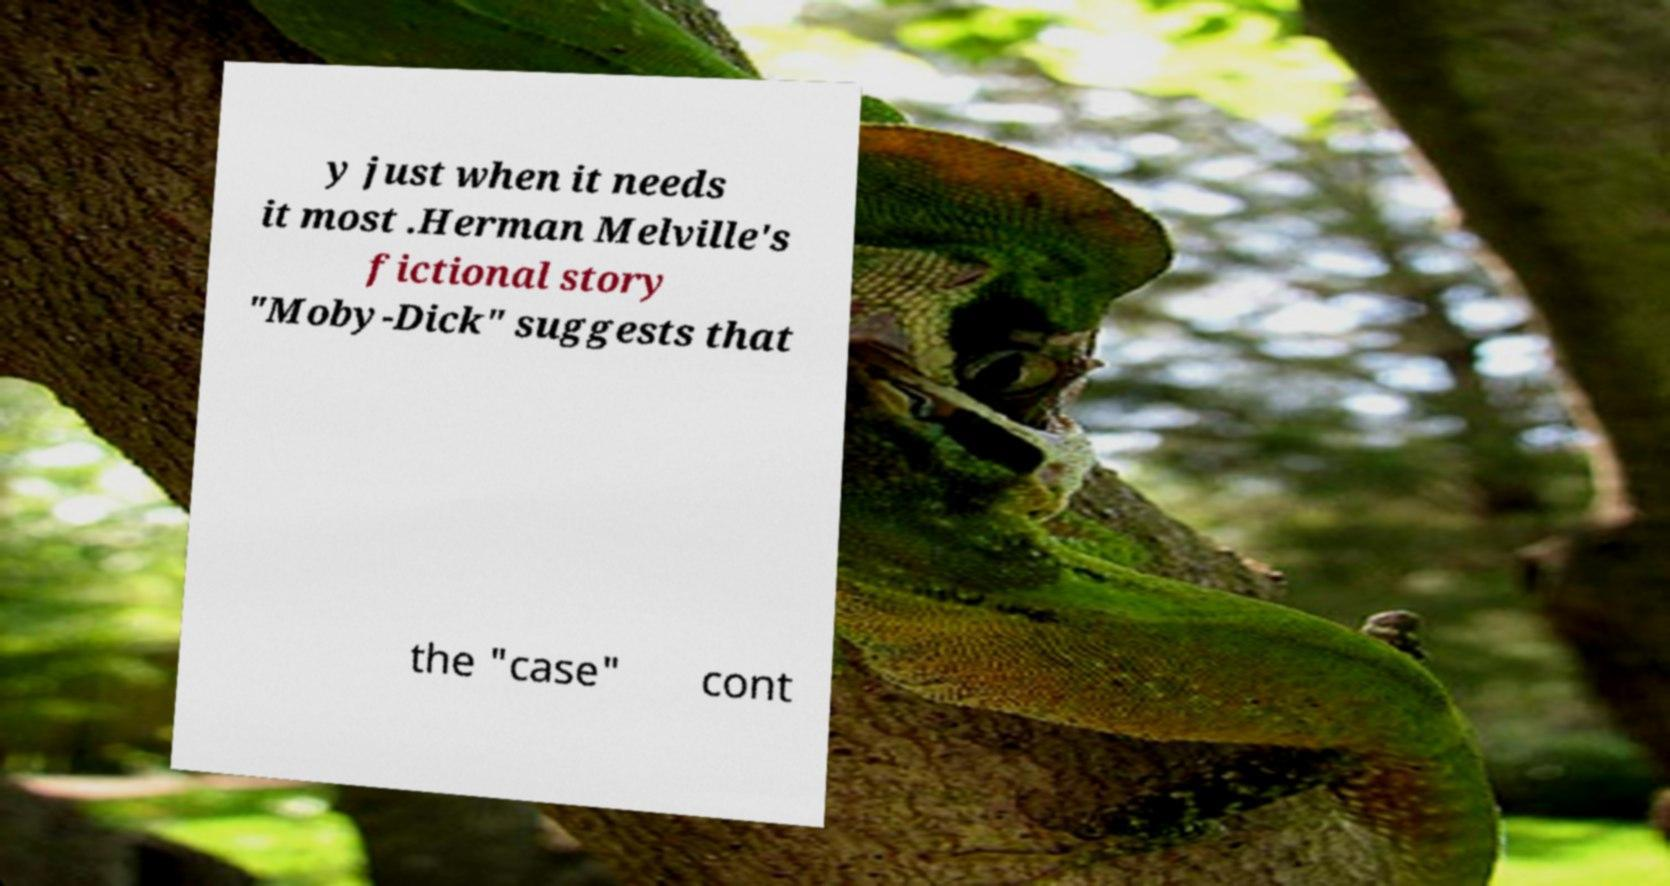Please identify and transcribe the text found in this image. y just when it needs it most .Herman Melville's fictional story "Moby-Dick" suggests that the "case" cont 